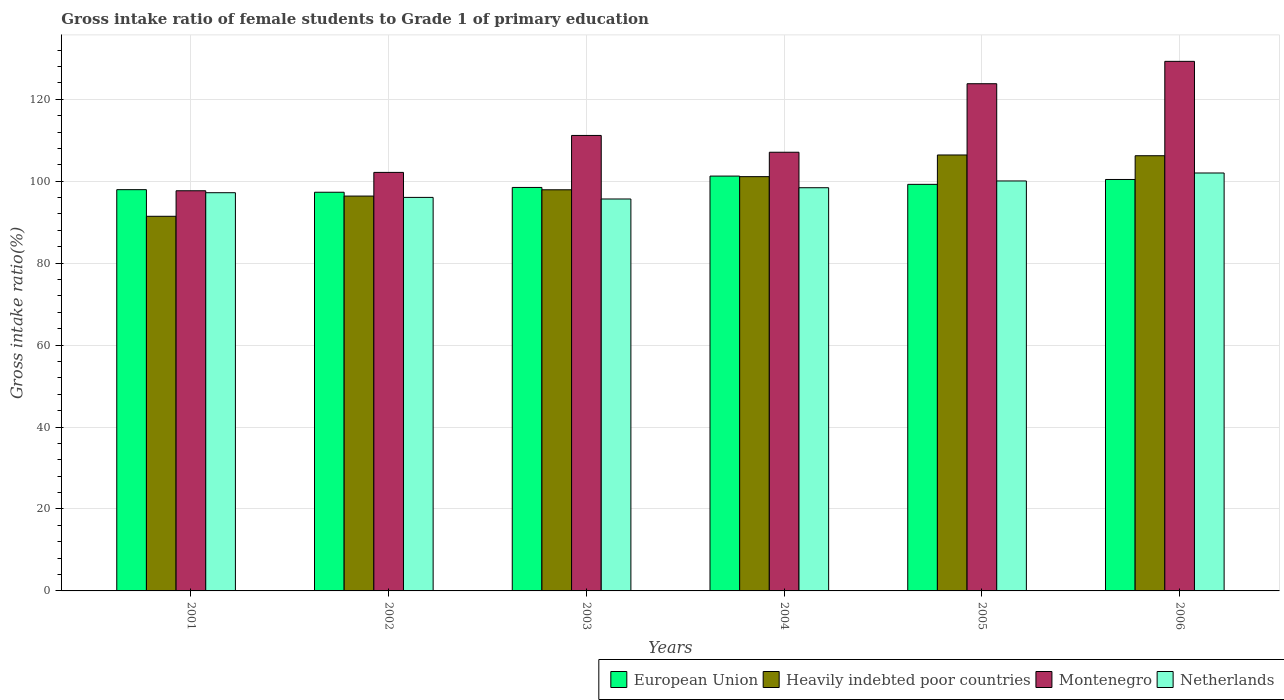How many different coloured bars are there?
Your answer should be compact. 4. How many groups of bars are there?
Your response must be concise. 6. How many bars are there on the 5th tick from the right?
Your answer should be very brief. 4. What is the label of the 1st group of bars from the left?
Provide a short and direct response. 2001. In how many cases, is the number of bars for a given year not equal to the number of legend labels?
Keep it short and to the point. 0. What is the gross intake ratio in Netherlands in 2001?
Make the answer very short. 97.19. Across all years, what is the maximum gross intake ratio in European Union?
Provide a short and direct response. 101.25. Across all years, what is the minimum gross intake ratio in Netherlands?
Give a very brief answer. 95.65. In which year was the gross intake ratio in Heavily indebted poor countries maximum?
Make the answer very short. 2005. What is the total gross intake ratio in Netherlands in the graph?
Keep it short and to the point. 589.34. What is the difference between the gross intake ratio in Netherlands in 2001 and that in 2003?
Provide a succinct answer. 1.53. What is the difference between the gross intake ratio in Heavily indebted poor countries in 2005 and the gross intake ratio in Netherlands in 2006?
Provide a short and direct response. 4.4. What is the average gross intake ratio in European Union per year?
Offer a very short reply. 99.1. In the year 2001, what is the difference between the gross intake ratio in Montenegro and gross intake ratio in Heavily indebted poor countries?
Keep it short and to the point. 6.23. What is the ratio of the gross intake ratio in Netherlands in 2001 to that in 2006?
Your response must be concise. 0.95. Is the gross intake ratio in Netherlands in 2005 less than that in 2006?
Provide a short and direct response. Yes. What is the difference between the highest and the second highest gross intake ratio in Heavily indebted poor countries?
Your answer should be very brief. 0.18. What is the difference between the highest and the lowest gross intake ratio in European Union?
Your answer should be compact. 3.95. Is the sum of the gross intake ratio in Netherlands in 2001 and 2003 greater than the maximum gross intake ratio in Montenegro across all years?
Give a very brief answer. Yes. Is it the case that in every year, the sum of the gross intake ratio in Heavily indebted poor countries and gross intake ratio in Montenegro is greater than the sum of gross intake ratio in Netherlands and gross intake ratio in European Union?
Provide a succinct answer. No. What does the 1st bar from the left in 2003 represents?
Make the answer very short. European Union. What does the 4th bar from the right in 2004 represents?
Make the answer very short. European Union. How many bars are there?
Offer a very short reply. 24. Are all the bars in the graph horizontal?
Ensure brevity in your answer.  No. What is the difference between two consecutive major ticks on the Y-axis?
Your answer should be compact. 20. Are the values on the major ticks of Y-axis written in scientific E-notation?
Provide a succinct answer. No. Does the graph contain any zero values?
Your response must be concise. No. Where does the legend appear in the graph?
Offer a terse response. Bottom right. How are the legend labels stacked?
Offer a terse response. Horizontal. What is the title of the graph?
Your answer should be very brief. Gross intake ratio of female students to Grade 1 of primary education. Does "Colombia" appear as one of the legend labels in the graph?
Give a very brief answer. No. What is the label or title of the Y-axis?
Offer a very short reply. Gross intake ratio(%). What is the Gross intake ratio(%) of European Union in 2001?
Ensure brevity in your answer.  97.93. What is the Gross intake ratio(%) in Heavily indebted poor countries in 2001?
Your response must be concise. 91.43. What is the Gross intake ratio(%) of Montenegro in 2001?
Your answer should be very brief. 97.66. What is the Gross intake ratio(%) of Netherlands in 2001?
Keep it short and to the point. 97.19. What is the Gross intake ratio(%) in European Union in 2002?
Provide a succinct answer. 97.3. What is the Gross intake ratio(%) of Heavily indebted poor countries in 2002?
Offer a very short reply. 96.37. What is the Gross intake ratio(%) in Montenegro in 2002?
Offer a terse response. 102.15. What is the Gross intake ratio(%) of Netherlands in 2002?
Keep it short and to the point. 96.04. What is the Gross intake ratio(%) of European Union in 2003?
Keep it short and to the point. 98.47. What is the Gross intake ratio(%) in Heavily indebted poor countries in 2003?
Give a very brief answer. 97.9. What is the Gross intake ratio(%) of Montenegro in 2003?
Give a very brief answer. 111.16. What is the Gross intake ratio(%) of Netherlands in 2003?
Provide a short and direct response. 95.65. What is the Gross intake ratio(%) in European Union in 2004?
Your answer should be compact. 101.25. What is the Gross intake ratio(%) in Heavily indebted poor countries in 2004?
Your answer should be compact. 101.11. What is the Gross intake ratio(%) of Montenegro in 2004?
Keep it short and to the point. 107.06. What is the Gross intake ratio(%) in Netherlands in 2004?
Your response must be concise. 98.4. What is the Gross intake ratio(%) in European Union in 2005?
Provide a succinct answer. 99.23. What is the Gross intake ratio(%) in Heavily indebted poor countries in 2005?
Ensure brevity in your answer.  106.4. What is the Gross intake ratio(%) in Montenegro in 2005?
Provide a succinct answer. 123.79. What is the Gross intake ratio(%) in Netherlands in 2005?
Offer a terse response. 100.05. What is the Gross intake ratio(%) of European Union in 2006?
Offer a terse response. 100.42. What is the Gross intake ratio(%) of Heavily indebted poor countries in 2006?
Make the answer very short. 106.21. What is the Gross intake ratio(%) in Montenegro in 2006?
Offer a terse response. 129.25. What is the Gross intake ratio(%) in Netherlands in 2006?
Keep it short and to the point. 102. Across all years, what is the maximum Gross intake ratio(%) of European Union?
Your answer should be compact. 101.25. Across all years, what is the maximum Gross intake ratio(%) of Heavily indebted poor countries?
Your answer should be compact. 106.4. Across all years, what is the maximum Gross intake ratio(%) of Montenegro?
Give a very brief answer. 129.25. Across all years, what is the maximum Gross intake ratio(%) of Netherlands?
Your answer should be very brief. 102. Across all years, what is the minimum Gross intake ratio(%) in European Union?
Your answer should be compact. 97.3. Across all years, what is the minimum Gross intake ratio(%) in Heavily indebted poor countries?
Provide a succinct answer. 91.43. Across all years, what is the minimum Gross intake ratio(%) of Montenegro?
Give a very brief answer. 97.66. Across all years, what is the minimum Gross intake ratio(%) of Netherlands?
Give a very brief answer. 95.65. What is the total Gross intake ratio(%) of European Union in the graph?
Your answer should be very brief. 594.59. What is the total Gross intake ratio(%) in Heavily indebted poor countries in the graph?
Your response must be concise. 599.42. What is the total Gross intake ratio(%) in Montenegro in the graph?
Your answer should be compact. 671.07. What is the total Gross intake ratio(%) of Netherlands in the graph?
Your answer should be very brief. 589.34. What is the difference between the Gross intake ratio(%) in European Union in 2001 and that in 2002?
Offer a terse response. 0.63. What is the difference between the Gross intake ratio(%) in Heavily indebted poor countries in 2001 and that in 2002?
Offer a terse response. -4.93. What is the difference between the Gross intake ratio(%) of Montenegro in 2001 and that in 2002?
Offer a terse response. -4.48. What is the difference between the Gross intake ratio(%) in Netherlands in 2001 and that in 2002?
Provide a succinct answer. 1.14. What is the difference between the Gross intake ratio(%) of European Union in 2001 and that in 2003?
Ensure brevity in your answer.  -0.54. What is the difference between the Gross intake ratio(%) in Heavily indebted poor countries in 2001 and that in 2003?
Provide a short and direct response. -6.47. What is the difference between the Gross intake ratio(%) in Montenegro in 2001 and that in 2003?
Your answer should be compact. -13.5. What is the difference between the Gross intake ratio(%) of Netherlands in 2001 and that in 2003?
Your answer should be compact. 1.53. What is the difference between the Gross intake ratio(%) of European Union in 2001 and that in 2004?
Ensure brevity in your answer.  -3.31. What is the difference between the Gross intake ratio(%) in Heavily indebted poor countries in 2001 and that in 2004?
Make the answer very short. -9.67. What is the difference between the Gross intake ratio(%) of Montenegro in 2001 and that in 2004?
Provide a succinct answer. -9.4. What is the difference between the Gross intake ratio(%) in Netherlands in 2001 and that in 2004?
Ensure brevity in your answer.  -1.22. What is the difference between the Gross intake ratio(%) in European Union in 2001 and that in 2005?
Make the answer very short. -1.29. What is the difference between the Gross intake ratio(%) of Heavily indebted poor countries in 2001 and that in 2005?
Keep it short and to the point. -14.96. What is the difference between the Gross intake ratio(%) of Montenegro in 2001 and that in 2005?
Your answer should be very brief. -26.12. What is the difference between the Gross intake ratio(%) in Netherlands in 2001 and that in 2005?
Your response must be concise. -2.87. What is the difference between the Gross intake ratio(%) of European Union in 2001 and that in 2006?
Offer a terse response. -2.48. What is the difference between the Gross intake ratio(%) of Heavily indebted poor countries in 2001 and that in 2006?
Offer a terse response. -14.78. What is the difference between the Gross intake ratio(%) in Montenegro in 2001 and that in 2006?
Offer a very short reply. -31.58. What is the difference between the Gross intake ratio(%) in Netherlands in 2001 and that in 2006?
Offer a terse response. -4.81. What is the difference between the Gross intake ratio(%) of European Union in 2002 and that in 2003?
Make the answer very short. -1.17. What is the difference between the Gross intake ratio(%) of Heavily indebted poor countries in 2002 and that in 2003?
Keep it short and to the point. -1.53. What is the difference between the Gross intake ratio(%) in Montenegro in 2002 and that in 2003?
Ensure brevity in your answer.  -9.02. What is the difference between the Gross intake ratio(%) in Netherlands in 2002 and that in 2003?
Provide a succinct answer. 0.39. What is the difference between the Gross intake ratio(%) of European Union in 2002 and that in 2004?
Offer a terse response. -3.95. What is the difference between the Gross intake ratio(%) of Heavily indebted poor countries in 2002 and that in 2004?
Ensure brevity in your answer.  -4.74. What is the difference between the Gross intake ratio(%) of Montenegro in 2002 and that in 2004?
Your answer should be compact. -4.92. What is the difference between the Gross intake ratio(%) of Netherlands in 2002 and that in 2004?
Offer a terse response. -2.36. What is the difference between the Gross intake ratio(%) in European Union in 2002 and that in 2005?
Provide a succinct answer. -1.92. What is the difference between the Gross intake ratio(%) of Heavily indebted poor countries in 2002 and that in 2005?
Offer a very short reply. -10.03. What is the difference between the Gross intake ratio(%) of Montenegro in 2002 and that in 2005?
Your answer should be very brief. -21.64. What is the difference between the Gross intake ratio(%) in Netherlands in 2002 and that in 2005?
Your answer should be very brief. -4.01. What is the difference between the Gross intake ratio(%) of European Union in 2002 and that in 2006?
Your response must be concise. -3.12. What is the difference between the Gross intake ratio(%) in Heavily indebted poor countries in 2002 and that in 2006?
Offer a terse response. -9.85. What is the difference between the Gross intake ratio(%) in Montenegro in 2002 and that in 2006?
Offer a terse response. -27.1. What is the difference between the Gross intake ratio(%) of Netherlands in 2002 and that in 2006?
Your answer should be compact. -5.96. What is the difference between the Gross intake ratio(%) in European Union in 2003 and that in 2004?
Your response must be concise. -2.77. What is the difference between the Gross intake ratio(%) in Heavily indebted poor countries in 2003 and that in 2004?
Give a very brief answer. -3.21. What is the difference between the Gross intake ratio(%) of Montenegro in 2003 and that in 2004?
Provide a succinct answer. 4.1. What is the difference between the Gross intake ratio(%) of Netherlands in 2003 and that in 2004?
Your answer should be compact. -2.75. What is the difference between the Gross intake ratio(%) in European Union in 2003 and that in 2005?
Your answer should be very brief. -0.75. What is the difference between the Gross intake ratio(%) of Heavily indebted poor countries in 2003 and that in 2005?
Give a very brief answer. -8.49. What is the difference between the Gross intake ratio(%) in Montenegro in 2003 and that in 2005?
Offer a very short reply. -12.62. What is the difference between the Gross intake ratio(%) in Netherlands in 2003 and that in 2005?
Keep it short and to the point. -4.4. What is the difference between the Gross intake ratio(%) in European Union in 2003 and that in 2006?
Provide a succinct answer. -1.95. What is the difference between the Gross intake ratio(%) in Heavily indebted poor countries in 2003 and that in 2006?
Your response must be concise. -8.31. What is the difference between the Gross intake ratio(%) of Montenegro in 2003 and that in 2006?
Offer a terse response. -18.08. What is the difference between the Gross intake ratio(%) of Netherlands in 2003 and that in 2006?
Provide a succinct answer. -6.35. What is the difference between the Gross intake ratio(%) of European Union in 2004 and that in 2005?
Provide a short and direct response. 2.02. What is the difference between the Gross intake ratio(%) of Heavily indebted poor countries in 2004 and that in 2005?
Offer a terse response. -5.29. What is the difference between the Gross intake ratio(%) of Montenegro in 2004 and that in 2005?
Provide a short and direct response. -16.72. What is the difference between the Gross intake ratio(%) in Netherlands in 2004 and that in 2005?
Keep it short and to the point. -1.65. What is the difference between the Gross intake ratio(%) of European Union in 2004 and that in 2006?
Offer a terse response. 0.83. What is the difference between the Gross intake ratio(%) of Heavily indebted poor countries in 2004 and that in 2006?
Give a very brief answer. -5.11. What is the difference between the Gross intake ratio(%) in Montenegro in 2004 and that in 2006?
Provide a short and direct response. -22.18. What is the difference between the Gross intake ratio(%) of Netherlands in 2004 and that in 2006?
Keep it short and to the point. -3.6. What is the difference between the Gross intake ratio(%) in European Union in 2005 and that in 2006?
Offer a very short reply. -1.19. What is the difference between the Gross intake ratio(%) in Heavily indebted poor countries in 2005 and that in 2006?
Your response must be concise. 0.18. What is the difference between the Gross intake ratio(%) in Montenegro in 2005 and that in 2006?
Keep it short and to the point. -5.46. What is the difference between the Gross intake ratio(%) in Netherlands in 2005 and that in 2006?
Give a very brief answer. -1.95. What is the difference between the Gross intake ratio(%) of European Union in 2001 and the Gross intake ratio(%) of Heavily indebted poor countries in 2002?
Your response must be concise. 1.56. What is the difference between the Gross intake ratio(%) in European Union in 2001 and the Gross intake ratio(%) in Montenegro in 2002?
Your answer should be compact. -4.21. What is the difference between the Gross intake ratio(%) in European Union in 2001 and the Gross intake ratio(%) in Netherlands in 2002?
Make the answer very short. 1.89. What is the difference between the Gross intake ratio(%) of Heavily indebted poor countries in 2001 and the Gross intake ratio(%) of Montenegro in 2002?
Offer a very short reply. -10.71. What is the difference between the Gross intake ratio(%) of Heavily indebted poor countries in 2001 and the Gross intake ratio(%) of Netherlands in 2002?
Keep it short and to the point. -4.61. What is the difference between the Gross intake ratio(%) of Montenegro in 2001 and the Gross intake ratio(%) of Netherlands in 2002?
Provide a short and direct response. 1.62. What is the difference between the Gross intake ratio(%) of European Union in 2001 and the Gross intake ratio(%) of Heavily indebted poor countries in 2003?
Your answer should be compact. 0.03. What is the difference between the Gross intake ratio(%) in European Union in 2001 and the Gross intake ratio(%) in Montenegro in 2003?
Keep it short and to the point. -13.23. What is the difference between the Gross intake ratio(%) in European Union in 2001 and the Gross intake ratio(%) in Netherlands in 2003?
Provide a succinct answer. 2.28. What is the difference between the Gross intake ratio(%) in Heavily indebted poor countries in 2001 and the Gross intake ratio(%) in Montenegro in 2003?
Offer a very short reply. -19.73. What is the difference between the Gross intake ratio(%) of Heavily indebted poor countries in 2001 and the Gross intake ratio(%) of Netherlands in 2003?
Offer a terse response. -4.22. What is the difference between the Gross intake ratio(%) of Montenegro in 2001 and the Gross intake ratio(%) of Netherlands in 2003?
Give a very brief answer. 2.01. What is the difference between the Gross intake ratio(%) of European Union in 2001 and the Gross intake ratio(%) of Heavily indebted poor countries in 2004?
Provide a succinct answer. -3.18. What is the difference between the Gross intake ratio(%) of European Union in 2001 and the Gross intake ratio(%) of Montenegro in 2004?
Give a very brief answer. -9.13. What is the difference between the Gross intake ratio(%) in European Union in 2001 and the Gross intake ratio(%) in Netherlands in 2004?
Keep it short and to the point. -0.47. What is the difference between the Gross intake ratio(%) in Heavily indebted poor countries in 2001 and the Gross intake ratio(%) in Montenegro in 2004?
Your response must be concise. -15.63. What is the difference between the Gross intake ratio(%) of Heavily indebted poor countries in 2001 and the Gross intake ratio(%) of Netherlands in 2004?
Your answer should be compact. -6.97. What is the difference between the Gross intake ratio(%) of Montenegro in 2001 and the Gross intake ratio(%) of Netherlands in 2004?
Provide a short and direct response. -0.74. What is the difference between the Gross intake ratio(%) in European Union in 2001 and the Gross intake ratio(%) in Heavily indebted poor countries in 2005?
Your answer should be very brief. -8.46. What is the difference between the Gross intake ratio(%) of European Union in 2001 and the Gross intake ratio(%) of Montenegro in 2005?
Give a very brief answer. -25.85. What is the difference between the Gross intake ratio(%) in European Union in 2001 and the Gross intake ratio(%) in Netherlands in 2005?
Offer a very short reply. -2.12. What is the difference between the Gross intake ratio(%) in Heavily indebted poor countries in 2001 and the Gross intake ratio(%) in Montenegro in 2005?
Ensure brevity in your answer.  -32.35. What is the difference between the Gross intake ratio(%) in Heavily indebted poor countries in 2001 and the Gross intake ratio(%) in Netherlands in 2005?
Provide a short and direct response. -8.62. What is the difference between the Gross intake ratio(%) in Montenegro in 2001 and the Gross intake ratio(%) in Netherlands in 2005?
Keep it short and to the point. -2.39. What is the difference between the Gross intake ratio(%) in European Union in 2001 and the Gross intake ratio(%) in Heavily indebted poor countries in 2006?
Offer a terse response. -8.28. What is the difference between the Gross intake ratio(%) of European Union in 2001 and the Gross intake ratio(%) of Montenegro in 2006?
Make the answer very short. -31.31. What is the difference between the Gross intake ratio(%) in European Union in 2001 and the Gross intake ratio(%) in Netherlands in 2006?
Make the answer very short. -4.07. What is the difference between the Gross intake ratio(%) of Heavily indebted poor countries in 2001 and the Gross intake ratio(%) of Montenegro in 2006?
Your answer should be compact. -37.81. What is the difference between the Gross intake ratio(%) of Heavily indebted poor countries in 2001 and the Gross intake ratio(%) of Netherlands in 2006?
Offer a very short reply. -10.57. What is the difference between the Gross intake ratio(%) in Montenegro in 2001 and the Gross intake ratio(%) in Netherlands in 2006?
Offer a very short reply. -4.34. What is the difference between the Gross intake ratio(%) in European Union in 2002 and the Gross intake ratio(%) in Heavily indebted poor countries in 2003?
Keep it short and to the point. -0.6. What is the difference between the Gross intake ratio(%) in European Union in 2002 and the Gross intake ratio(%) in Montenegro in 2003?
Ensure brevity in your answer.  -13.86. What is the difference between the Gross intake ratio(%) in European Union in 2002 and the Gross intake ratio(%) in Netherlands in 2003?
Provide a short and direct response. 1.65. What is the difference between the Gross intake ratio(%) of Heavily indebted poor countries in 2002 and the Gross intake ratio(%) of Montenegro in 2003?
Provide a short and direct response. -14.8. What is the difference between the Gross intake ratio(%) of Heavily indebted poor countries in 2002 and the Gross intake ratio(%) of Netherlands in 2003?
Your response must be concise. 0.71. What is the difference between the Gross intake ratio(%) of Montenegro in 2002 and the Gross intake ratio(%) of Netherlands in 2003?
Provide a short and direct response. 6.49. What is the difference between the Gross intake ratio(%) in European Union in 2002 and the Gross intake ratio(%) in Heavily indebted poor countries in 2004?
Offer a terse response. -3.81. What is the difference between the Gross intake ratio(%) of European Union in 2002 and the Gross intake ratio(%) of Montenegro in 2004?
Offer a very short reply. -9.76. What is the difference between the Gross intake ratio(%) in European Union in 2002 and the Gross intake ratio(%) in Netherlands in 2004?
Keep it short and to the point. -1.1. What is the difference between the Gross intake ratio(%) of Heavily indebted poor countries in 2002 and the Gross intake ratio(%) of Montenegro in 2004?
Provide a succinct answer. -10.7. What is the difference between the Gross intake ratio(%) of Heavily indebted poor countries in 2002 and the Gross intake ratio(%) of Netherlands in 2004?
Your answer should be compact. -2.04. What is the difference between the Gross intake ratio(%) of Montenegro in 2002 and the Gross intake ratio(%) of Netherlands in 2004?
Offer a very short reply. 3.74. What is the difference between the Gross intake ratio(%) of European Union in 2002 and the Gross intake ratio(%) of Heavily indebted poor countries in 2005?
Offer a terse response. -9.1. What is the difference between the Gross intake ratio(%) in European Union in 2002 and the Gross intake ratio(%) in Montenegro in 2005?
Offer a very short reply. -26.49. What is the difference between the Gross intake ratio(%) in European Union in 2002 and the Gross intake ratio(%) in Netherlands in 2005?
Keep it short and to the point. -2.75. What is the difference between the Gross intake ratio(%) in Heavily indebted poor countries in 2002 and the Gross intake ratio(%) in Montenegro in 2005?
Your answer should be very brief. -27.42. What is the difference between the Gross intake ratio(%) in Heavily indebted poor countries in 2002 and the Gross intake ratio(%) in Netherlands in 2005?
Provide a short and direct response. -3.69. What is the difference between the Gross intake ratio(%) of Montenegro in 2002 and the Gross intake ratio(%) of Netherlands in 2005?
Offer a terse response. 2.09. What is the difference between the Gross intake ratio(%) in European Union in 2002 and the Gross intake ratio(%) in Heavily indebted poor countries in 2006?
Give a very brief answer. -8.91. What is the difference between the Gross intake ratio(%) in European Union in 2002 and the Gross intake ratio(%) in Montenegro in 2006?
Provide a succinct answer. -31.95. What is the difference between the Gross intake ratio(%) of European Union in 2002 and the Gross intake ratio(%) of Netherlands in 2006?
Give a very brief answer. -4.7. What is the difference between the Gross intake ratio(%) of Heavily indebted poor countries in 2002 and the Gross intake ratio(%) of Montenegro in 2006?
Give a very brief answer. -32.88. What is the difference between the Gross intake ratio(%) in Heavily indebted poor countries in 2002 and the Gross intake ratio(%) in Netherlands in 2006?
Provide a short and direct response. -5.63. What is the difference between the Gross intake ratio(%) of Montenegro in 2002 and the Gross intake ratio(%) of Netherlands in 2006?
Ensure brevity in your answer.  0.15. What is the difference between the Gross intake ratio(%) of European Union in 2003 and the Gross intake ratio(%) of Heavily indebted poor countries in 2004?
Your answer should be very brief. -2.64. What is the difference between the Gross intake ratio(%) of European Union in 2003 and the Gross intake ratio(%) of Montenegro in 2004?
Offer a terse response. -8.59. What is the difference between the Gross intake ratio(%) of European Union in 2003 and the Gross intake ratio(%) of Netherlands in 2004?
Ensure brevity in your answer.  0.07. What is the difference between the Gross intake ratio(%) of Heavily indebted poor countries in 2003 and the Gross intake ratio(%) of Montenegro in 2004?
Provide a succinct answer. -9.16. What is the difference between the Gross intake ratio(%) in Heavily indebted poor countries in 2003 and the Gross intake ratio(%) in Netherlands in 2004?
Your answer should be very brief. -0.5. What is the difference between the Gross intake ratio(%) of Montenegro in 2003 and the Gross intake ratio(%) of Netherlands in 2004?
Keep it short and to the point. 12.76. What is the difference between the Gross intake ratio(%) of European Union in 2003 and the Gross intake ratio(%) of Heavily indebted poor countries in 2005?
Your answer should be compact. -7.92. What is the difference between the Gross intake ratio(%) of European Union in 2003 and the Gross intake ratio(%) of Montenegro in 2005?
Your response must be concise. -25.32. What is the difference between the Gross intake ratio(%) in European Union in 2003 and the Gross intake ratio(%) in Netherlands in 2005?
Your response must be concise. -1.58. What is the difference between the Gross intake ratio(%) of Heavily indebted poor countries in 2003 and the Gross intake ratio(%) of Montenegro in 2005?
Provide a short and direct response. -25.89. What is the difference between the Gross intake ratio(%) of Heavily indebted poor countries in 2003 and the Gross intake ratio(%) of Netherlands in 2005?
Make the answer very short. -2.15. What is the difference between the Gross intake ratio(%) of Montenegro in 2003 and the Gross intake ratio(%) of Netherlands in 2005?
Provide a succinct answer. 11.11. What is the difference between the Gross intake ratio(%) in European Union in 2003 and the Gross intake ratio(%) in Heavily indebted poor countries in 2006?
Keep it short and to the point. -7.74. What is the difference between the Gross intake ratio(%) of European Union in 2003 and the Gross intake ratio(%) of Montenegro in 2006?
Offer a terse response. -30.77. What is the difference between the Gross intake ratio(%) of European Union in 2003 and the Gross intake ratio(%) of Netherlands in 2006?
Ensure brevity in your answer.  -3.53. What is the difference between the Gross intake ratio(%) in Heavily indebted poor countries in 2003 and the Gross intake ratio(%) in Montenegro in 2006?
Your response must be concise. -31.34. What is the difference between the Gross intake ratio(%) in Heavily indebted poor countries in 2003 and the Gross intake ratio(%) in Netherlands in 2006?
Offer a very short reply. -4.1. What is the difference between the Gross intake ratio(%) of Montenegro in 2003 and the Gross intake ratio(%) of Netherlands in 2006?
Your answer should be very brief. 9.16. What is the difference between the Gross intake ratio(%) in European Union in 2004 and the Gross intake ratio(%) in Heavily indebted poor countries in 2005?
Offer a terse response. -5.15. What is the difference between the Gross intake ratio(%) of European Union in 2004 and the Gross intake ratio(%) of Montenegro in 2005?
Provide a succinct answer. -22.54. What is the difference between the Gross intake ratio(%) of European Union in 2004 and the Gross intake ratio(%) of Netherlands in 2005?
Your response must be concise. 1.19. What is the difference between the Gross intake ratio(%) of Heavily indebted poor countries in 2004 and the Gross intake ratio(%) of Montenegro in 2005?
Make the answer very short. -22.68. What is the difference between the Gross intake ratio(%) of Heavily indebted poor countries in 2004 and the Gross intake ratio(%) of Netherlands in 2005?
Your response must be concise. 1.05. What is the difference between the Gross intake ratio(%) in Montenegro in 2004 and the Gross intake ratio(%) in Netherlands in 2005?
Ensure brevity in your answer.  7.01. What is the difference between the Gross intake ratio(%) in European Union in 2004 and the Gross intake ratio(%) in Heavily indebted poor countries in 2006?
Make the answer very short. -4.97. What is the difference between the Gross intake ratio(%) of European Union in 2004 and the Gross intake ratio(%) of Montenegro in 2006?
Provide a short and direct response. -28. What is the difference between the Gross intake ratio(%) of European Union in 2004 and the Gross intake ratio(%) of Netherlands in 2006?
Give a very brief answer. -0.75. What is the difference between the Gross intake ratio(%) of Heavily indebted poor countries in 2004 and the Gross intake ratio(%) of Montenegro in 2006?
Offer a very short reply. -28.14. What is the difference between the Gross intake ratio(%) of Heavily indebted poor countries in 2004 and the Gross intake ratio(%) of Netherlands in 2006?
Your answer should be very brief. -0.89. What is the difference between the Gross intake ratio(%) of Montenegro in 2004 and the Gross intake ratio(%) of Netherlands in 2006?
Give a very brief answer. 5.06. What is the difference between the Gross intake ratio(%) in European Union in 2005 and the Gross intake ratio(%) in Heavily indebted poor countries in 2006?
Make the answer very short. -6.99. What is the difference between the Gross intake ratio(%) in European Union in 2005 and the Gross intake ratio(%) in Montenegro in 2006?
Your response must be concise. -30.02. What is the difference between the Gross intake ratio(%) of European Union in 2005 and the Gross intake ratio(%) of Netherlands in 2006?
Your answer should be very brief. -2.77. What is the difference between the Gross intake ratio(%) in Heavily indebted poor countries in 2005 and the Gross intake ratio(%) in Montenegro in 2006?
Give a very brief answer. -22.85. What is the difference between the Gross intake ratio(%) of Heavily indebted poor countries in 2005 and the Gross intake ratio(%) of Netherlands in 2006?
Make the answer very short. 4.4. What is the difference between the Gross intake ratio(%) of Montenegro in 2005 and the Gross intake ratio(%) of Netherlands in 2006?
Give a very brief answer. 21.79. What is the average Gross intake ratio(%) in European Union per year?
Provide a succinct answer. 99.1. What is the average Gross intake ratio(%) of Heavily indebted poor countries per year?
Provide a short and direct response. 99.9. What is the average Gross intake ratio(%) of Montenegro per year?
Offer a terse response. 111.85. What is the average Gross intake ratio(%) in Netherlands per year?
Make the answer very short. 98.22. In the year 2001, what is the difference between the Gross intake ratio(%) in European Union and Gross intake ratio(%) in Heavily indebted poor countries?
Keep it short and to the point. 6.5. In the year 2001, what is the difference between the Gross intake ratio(%) of European Union and Gross intake ratio(%) of Montenegro?
Ensure brevity in your answer.  0.27. In the year 2001, what is the difference between the Gross intake ratio(%) of European Union and Gross intake ratio(%) of Netherlands?
Your answer should be very brief. 0.74. In the year 2001, what is the difference between the Gross intake ratio(%) of Heavily indebted poor countries and Gross intake ratio(%) of Montenegro?
Offer a very short reply. -6.23. In the year 2001, what is the difference between the Gross intake ratio(%) of Heavily indebted poor countries and Gross intake ratio(%) of Netherlands?
Provide a short and direct response. -5.75. In the year 2001, what is the difference between the Gross intake ratio(%) of Montenegro and Gross intake ratio(%) of Netherlands?
Give a very brief answer. 0.48. In the year 2002, what is the difference between the Gross intake ratio(%) of European Union and Gross intake ratio(%) of Heavily indebted poor countries?
Ensure brevity in your answer.  0.93. In the year 2002, what is the difference between the Gross intake ratio(%) in European Union and Gross intake ratio(%) in Montenegro?
Make the answer very short. -4.85. In the year 2002, what is the difference between the Gross intake ratio(%) in European Union and Gross intake ratio(%) in Netherlands?
Make the answer very short. 1.26. In the year 2002, what is the difference between the Gross intake ratio(%) in Heavily indebted poor countries and Gross intake ratio(%) in Montenegro?
Keep it short and to the point. -5.78. In the year 2002, what is the difference between the Gross intake ratio(%) in Heavily indebted poor countries and Gross intake ratio(%) in Netherlands?
Give a very brief answer. 0.32. In the year 2002, what is the difference between the Gross intake ratio(%) of Montenegro and Gross intake ratio(%) of Netherlands?
Your response must be concise. 6.1. In the year 2003, what is the difference between the Gross intake ratio(%) in European Union and Gross intake ratio(%) in Heavily indebted poor countries?
Your answer should be compact. 0.57. In the year 2003, what is the difference between the Gross intake ratio(%) of European Union and Gross intake ratio(%) of Montenegro?
Give a very brief answer. -12.69. In the year 2003, what is the difference between the Gross intake ratio(%) of European Union and Gross intake ratio(%) of Netherlands?
Keep it short and to the point. 2.82. In the year 2003, what is the difference between the Gross intake ratio(%) in Heavily indebted poor countries and Gross intake ratio(%) in Montenegro?
Provide a succinct answer. -13.26. In the year 2003, what is the difference between the Gross intake ratio(%) of Heavily indebted poor countries and Gross intake ratio(%) of Netherlands?
Ensure brevity in your answer.  2.25. In the year 2003, what is the difference between the Gross intake ratio(%) in Montenegro and Gross intake ratio(%) in Netherlands?
Make the answer very short. 15.51. In the year 2004, what is the difference between the Gross intake ratio(%) in European Union and Gross intake ratio(%) in Heavily indebted poor countries?
Keep it short and to the point. 0.14. In the year 2004, what is the difference between the Gross intake ratio(%) in European Union and Gross intake ratio(%) in Montenegro?
Your answer should be compact. -5.82. In the year 2004, what is the difference between the Gross intake ratio(%) of European Union and Gross intake ratio(%) of Netherlands?
Your answer should be compact. 2.84. In the year 2004, what is the difference between the Gross intake ratio(%) in Heavily indebted poor countries and Gross intake ratio(%) in Montenegro?
Your answer should be compact. -5.96. In the year 2004, what is the difference between the Gross intake ratio(%) of Heavily indebted poor countries and Gross intake ratio(%) of Netherlands?
Your answer should be compact. 2.7. In the year 2004, what is the difference between the Gross intake ratio(%) of Montenegro and Gross intake ratio(%) of Netherlands?
Keep it short and to the point. 8.66. In the year 2005, what is the difference between the Gross intake ratio(%) of European Union and Gross intake ratio(%) of Heavily indebted poor countries?
Your answer should be very brief. -7.17. In the year 2005, what is the difference between the Gross intake ratio(%) in European Union and Gross intake ratio(%) in Montenegro?
Your answer should be compact. -24.56. In the year 2005, what is the difference between the Gross intake ratio(%) in European Union and Gross intake ratio(%) in Netherlands?
Make the answer very short. -0.83. In the year 2005, what is the difference between the Gross intake ratio(%) of Heavily indebted poor countries and Gross intake ratio(%) of Montenegro?
Ensure brevity in your answer.  -17.39. In the year 2005, what is the difference between the Gross intake ratio(%) in Heavily indebted poor countries and Gross intake ratio(%) in Netherlands?
Your answer should be very brief. 6.34. In the year 2005, what is the difference between the Gross intake ratio(%) of Montenegro and Gross intake ratio(%) of Netherlands?
Your answer should be very brief. 23.73. In the year 2006, what is the difference between the Gross intake ratio(%) in European Union and Gross intake ratio(%) in Heavily indebted poor countries?
Provide a short and direct response. -5.8. In the year 2006, what is the difference between the Gross intake ratio(%) of European Union and Gross intake ratio(%) of Montenegro?
Ensure brevity in your answer.  -28.83. In the year 2006, what is the difference between the Gross intake ratio(%) in European Union and Gross intake ratio(%) in Netherlands?
Offer a very short reply. -1.58. In the year 2006, what is the difference between the Gross intake ratio(%) of Heavily indebted poor countries and Gross intake ratio(%) of Montenegro?
Offer a very short reply. -23.03. In the year 2006, what is the difference between the Gross intake ratio(%) in Heavily indebted poor countries and Gross intake ratio(%) in Netherlands?
Offer a terse response. 4.21. In the year 2006, what is the difference between the Gross intake ratio(%) in Montenegro and Gross intake ratio(%) in Netherlands?
Your response must be concise. 27.25. What is the ratio of the Gross intake ratio(%) of Heavily indebted poor countries in 2001 to that in 2002?
Offer a very short reply. 0.95. What is the ratio of the Gross intake ratio(%) in Montenegro in 2001 to that in 2002?
Offer a very short reply. 0.96. What is the ratio of the Gross intake ratio(%) of Netherlands in 2001 to that in 2002?
Provide a short and direct response. 1.01. What is the ratio of the Gross intake ratio(%) in Heavily indebted poor countries in 2001 to that in 2003?
Your response must be concise. 0.93. What is the ratio of the Gross intake ratio(%) in Montenegro in 2001 to that in 2003?
Provide a succinct answer. 0.88. What is the ratio of the Gross intake ratio(%) in Netherlands in 2001 to that in 2003?
Give a very brief answer. 1.02. What is the ratio of the Gross intake ratio(%) in European Union in 2001 to that in 2004?
Offer a terse response. 0.97. What is the ratio of the Gross intake ratio(%) of Heavily indebted poor countries in 2001 to that in 2004?
Make the answer very short. 0.9. What is the ratio of the Gross intake ratio(%) in Montenegro in 2001 to that in 2004?
Make the answer very short. 0.91. What is the ratio of the Gross intake ratio(%) in Netherlands in 2001 to that in 2004?
Make the answer very short. 0.99. What is the ratio of the Gross intake ratio(%) in Heavily indebted poor countries in 2001 to that in 2005?
Provide a short and direct response. 0.86. What is the ratio of the Gross intake ratio(%) of Montenegro in 2001 to that in 2005?
Provide a succinct answer. 0.79. What is the ratio of the Gross intake ratio(%) of Netherlands in 2001 to that in 2005?
Give a very brief answer. 0.97. What is the ratio of the Gross intake ratio(%) of European Union in 2001 to that in 2006?
Provide a succinct answer. 0.98. What is the ratio of the Gross intake ratio(%) of Heavily indebted poor countries in 2001 to that in 2006?
Make the answer very short. 0.86. What is the ratio of the Gross intake ratio(%) in Montenegro in 2001 to that in 2006?
Provide a succinct answer. 0.76. What is the ratio of the Gross intake ratio(%) in Netherlands in 2001 to that in 2006?
Your answer should be very brief. 0.95. What is the ratio of the Gross intake ratio(%) in Heavily indebted poor countries in 2002 to that in 2003?
Provide a succinct answer. 0.98. What is the ratio of the Gross intake ratio(%) of Montenegro in 2002 to that in 2003?
Ensure brevity in your answer.  0.92. What is the ratio of the Gross intake ratio(%) of Heavily indebted poor countries in 2002 to that in 2004?
Ensure brevity in your answer.  0.95. What is the ratio of the Gross intake ratio(%) of Montenegro in 2002 to that in 2004?
Provide a succinct answer. 0.95. What is the ratio of the Gross intake ratio(%) in Netherlands in 2002 to that in 2004?
Offer a very short reply. 0.98. What is the ratio of the Gross intake ratio(%) in European Union in 2002 to that in 2005?
Keep it short and to the point. 0.98. What is the ratio of the Gross intake ratio(%) in Heavily indebted poor countries in 2002 to that in 2005?
Make the answer very short. 0.91. What is the ratio of the Gross intake ratio(%) in Montenegro in 2002 to that in 2005?
Offer a very short reply. 0.83. What is the ratio of the Gross intake ratio(%) of Netherlands in 2002 to that in 2005?
Your response must be concise. 0.96. What is the ratio of the Gross intake ratio(%) of Heavily indebted poor countries in 2002 to that in 2006?
Keep it short and to the point. 0.91. What is the ratio of the Gross intake ratio(%) in Montenegro in 2002 to that in 2006?
Your answer should be compact. 0.79. What is the ratio of the Gross intake ratio(%) in Netherlands in 2002 to that in 2006?
Your response must be concise. 0.94. What is the ratio of the Gross intake ratio(%) in European Union in 2003 to that in 2004?
Your response must be concise. 0.97. What is the ratio of the Gross intake ratio(%) in Heavily indebted poor countries in 2003 to that in 2004?
Ensure brevity in your answer.  0.97. What is the ratio of the Gross intake ratio(%) in Montenegro in 2003 to that in 2004?
Your response must be concise. 1.04. What is the ratio of the Gross intake ratio(%) in European Union in 2003 to that in 2005?
Give a very brief answer. 0.99. What is the ratio of the Gross intake ratio(%) in Heavily indebted poor countries in 2003 to that in 2005?
Your response must be concise. 0.92. What is the ratio of the Gross intake ratio(%) of Montenegro in 2003 to that in 2005?
Your answer should be very brief. 0.9. What is the ratio of the Gross intake ratio(%) of Netherlands in 2003 to that in 2005?
Make the answer very short. 0.96. What is the ratio of the Gross intake ratio(%) of European Union in 2003 to that in 2006?
Offer a terse response. 0.98. What is the ratio of the Gross intake ratio(%) in Heavily indebted poor countries in 2003 to that in 2006?
Give a very brief answer. 0.92. What is the ratio of the Gross intake ratio(%) of Montenegro in 2003 to that in 2006?
Your answer should be compact. 0.86. What is the ratio of the Gross intake ratio(%) in Netherlands in 2003 to that in 2006?
Provide a short and direct response. 0.94. What is the ratio of the Gross intake ratio(%) of European Union in 2004 to that in 2005?
Provide a short and direct response. 1.02. What is the ratio of the Gross intake ratio(%) of Heavily indebted poor countries in 2004 to that in 2005?
Offer a terse response. 0.95. What is the ratio of the Gross intake ratio(%) of Montenegro in 2004 to that in 2005?
Make the answer very short. 0.86. What is the ratio of the Gross intake ratio(%) in Netherlands in 2004 to that in 2005?
Offer a terse response. 0.98. What is the ratio of the Gross intake ratio(%) of European Union in 2004 to that in 2006?
Keep it short and to the point. 1.01. What is the ratio of the Gross intake ratio(%) in Heavily indebted poor countries in 2004 to that in 2006?
Your response must be concise. 0.95. What is the ratio of the Gross intake ratio(%) in Montenegro in 2004 to that in 2006?
Your response must be concise. 0.83. What is the ratio of the Gross intake ratio(%) of Netherlands in 2004 to that in 2006?
Offer a terse response. 0.96. What is the ratio of the Gross intake ratio(%) in Heavily indebted poor countries in 2005 to that in 2006?
Offer a very short reply. 1. What is the ratio of the Gross intake ratio(%) in Montenegro in 2005 to that in 2006?
Keep it short and to the point. 0.96. What is the ratio of the Gross intake ratio(%) of Netherlands in 2005 to that in 2006?
Ensure brevity in your answer.  0.98. What is the difference between the highest and the second highest Gross intake ratio(%) of European Union?
Offer a very short reply. 0.83. What is the difference between the highest and the second highest Gross intake ratio(%) in Heavily indebted poor countries?
Provide a short and direct response. 0.18. What is the difference between the highest and the second highest Gross intake ratio(%) of Montenegro?
Provide a succinct answer. 5.46. What is the difference between the highest and the second highest Gross intake ratio(%) in Netherlands?
Provide a short and direct response. 1.95. What is the difference between the highest and the lowest Gross intake ratio(%) of European Union?
Offer a terse response. 3.95. What is the difference between the highest and the lowest Gross intake ratio(%) of Heavily indebted poor countries?
Ensure brevity in your answer.  14.96. What is the difference between the highest and the lowest Gross intake ratio(%) in Montenegro?
Keep it short and to the point. 31.58. What is the difference between the highest and the lowest Gross intake ratio(%) in Netherlands?
Keep it short and to the point. 6.35. 